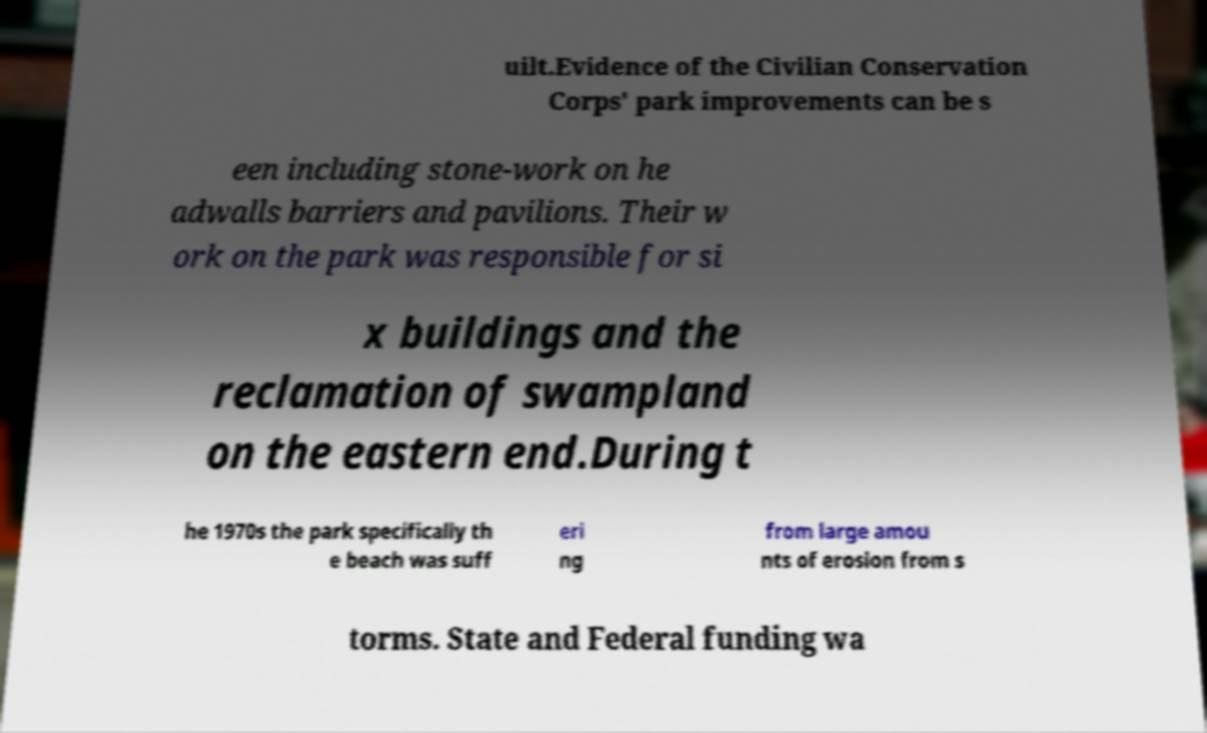For documentation purposes, I need the text within this image transcribed. Could you provide that? uilt.Evidence of the Civilian Conservation Corps' park improvements can be s een including stone-work on he adwalls barriers and pavilions. Their w ork on the park was responsible for si x buildings and the reclamation of swampland on the eastern end.During t he 1970s the park specifically th e beach was suff eri ng from large amou nts of erosion from s torms. State and Federal funding wa 